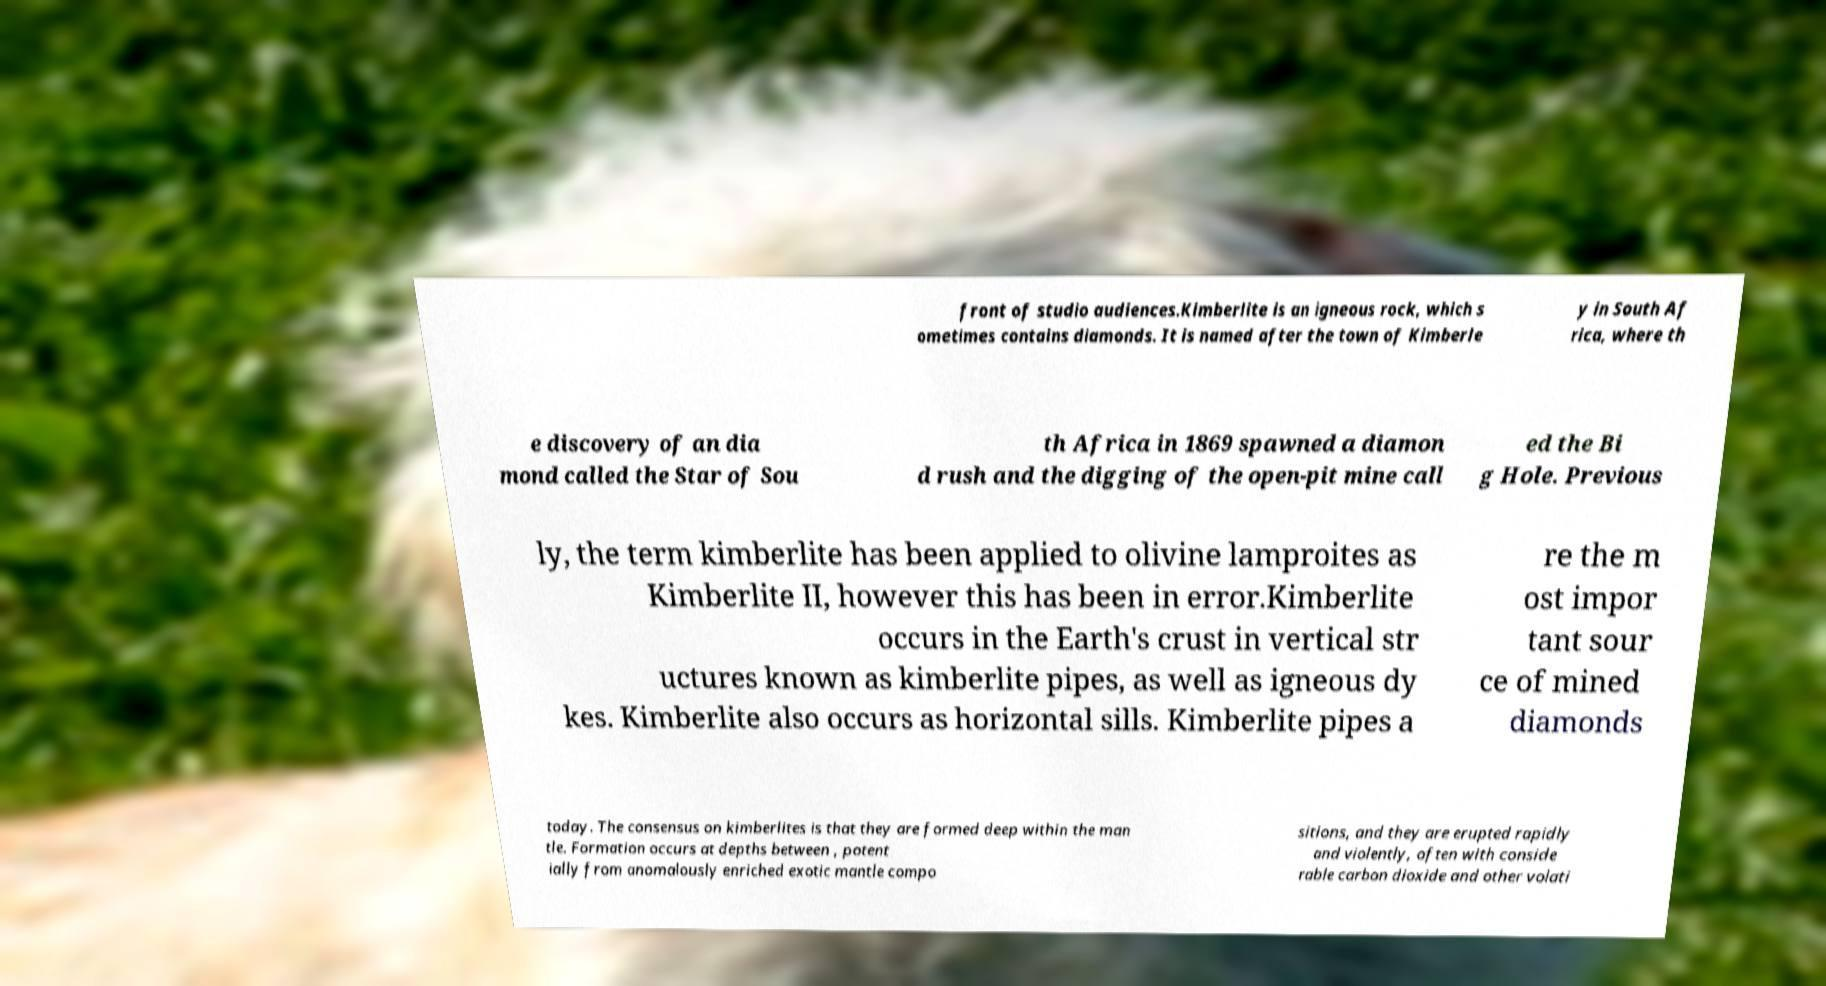There's text embedded in this image that I need extracted. Can you transcribe it verbatim? front of studio audiences.Kimberlite is an igneous rock, which s ometimes contains diamonds. It is named after the town of Kimberle y in South Af rica, where th e discovery of an dia mond called the Star of Sou th Africa in 1869 spawned a diamon d rush and the digging of the open-pit mine call ed the Bi g Hole. Previous ly, the term kimberlite has been applied to olivine lamproites as Kimberlite II, however this has been in error.Kimberlite occurs in the Earth's crust in vertical str uctures known as kimberlite pipes, as well as igneous dy kes. Kimberlite also occurs as horizontal sills. Kimberlite pipes a re the m ost impor tant sour ce of mined diamonds today. The consensus on kimberlites is that they are formed deep within the man tle. Formation occurs at depths between , potent ially from anomalously enriched exotic mantle compo sitions, and they are erupted rapidly and violently, often with conside rable carbon dioxide and other volati 